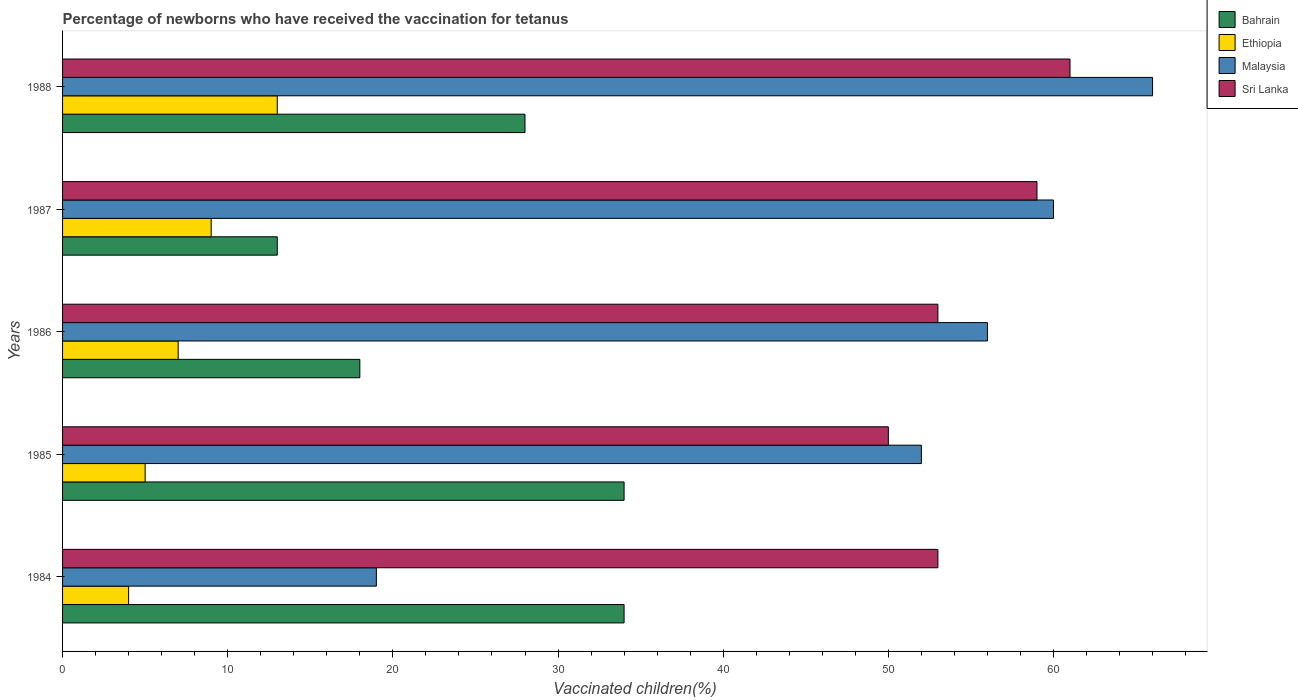Are the number of bars on each tick of the Y-axis equal?
Keep it short and to the point. Yes. How many bars are there on the 3rd tick from the top?
Keep it short and to the point. 4. What is the label of the 4th group of bars from the top?
Give a very brief answer. 1985. Across all years, what is the minimum percentage of vaccinated children in Sri Lanka?
Ensure brevity in your answer.  50. In which year was the percentage of vaccinated children in Malaysia minimum?
Offer a very short reply. 1984. What is the total percentage of vaccinated children in Malaysia in the graph?
Provide a short and direct response. 253. What is the difference between the percentage of vaccinated children in Sri Lanka in 1987 and that in 1988?
Ensure brevity in your answer.  -2. What is the difference between the percentage of vaccinated children in Bahrain in 1984 and the percentage of vaccinated children in Malaysia in 1986?
Your answer should be very brief. -22. What is the average percentage of vaccinated children in Malaysia per year?
Make the answer very short. 50.6. In the year 1988, what is the difference between the percentage of vaccinated children in Malaysia and percentage of vaccinated children in Ethiopia?
Your answer should be compact. 53. What is the ratio of the percentage of vaccinated children in Ethiopia in 1984 to that in 1988?
Offer a terse response. 0.31. Is the percentage of vaccinated children in Ethiopia in 1984 less than that in 1986?
Your answer should be compact. Yes. Is the difference between the percentage of vaccinated children in Malaysia in 1984 and 1987 greater than the difference between the percentage of vaccinated children in Ethiopia in 1984 and 1987?
Ensure brevity in your answer.  No. What is the difference between the highest and the lowest percentage of vaccinated children in Malaysia?
Provide a short and direct response. 47. Is the sum of the percentage of vaccinated children in Ethiopia in 1987 and 1988 greater than the maximum percentage of vaccinated children in Sri Lanka across all years?
Your response must be concise. No. What does the 4th bar from the top in 1986 represents?
Make the answer very short. Bahrain. What does the 2nd bar from the bottom in 1987 represents?
Give a very brief answer. Ethiopia. How many bars are there?
Offer a terse response. 20. Are all the bars in the graph horizontal?
Your answer should be compact. Yes. How many years are there in the graph?
Keep it short and to the point. 5. Are the values on the major ticks of X-axis written in scientific E-notation?
Offer a terse response. No. Where does the legend appear in the graph?
Keep it short and to the point. Top right. How many legend labels are there?
Provide a short and direct response. 4. How are the legend labels stacked?
Provide a succinct answer. Vertical. What is the title of the graph?
Your response must be concise. Percentage of newborns who have received the vaccination for tetanus. What is the label or title of the X-axis?
Keep it short and to the point. Vaccinated children(%). What is the Vaccinated children(%) of Bahrain in 1984?
Offer a very short reply. 34. What is the Vaccinated children(%) of Bahrain in 1985?
Keep it short and to the point. 34. What is the Vaccinated children(%) of Malaysia in 1985?
Provide a succinct answer. 52. What is the Vaccinated children(%) of Sri Lanka in 1985?
Ensure brevity in your answer.  50. What is the Vaccinated children(%) of Ethiopia in 1986?
Ensure brevity in your answer.  7. What is the Vaccinated children(%) of Malaysia in 1986?
Provide a succinct answer. 56. What is the Vaccinated children(%) of Bahrain in 1987?
Your answer should be compact. 13. What is the Vaccinated children(%) in Ethiopia in 1987?
Give a very brief answer. 9. What is the Vaccinated children(%) in Malaysia in 1987?
Provide a short and direct response. 60. What is the Vaccinated children(%) in Bahrain in 1988?
Make the answer very short. 28. What is the Vaccinated children(%) in Ethiopia in 1988?
Your answer should be compact. 13. What is the Vaccinated children(%) of Sri Lanka in 1988?
Ensure brevity in your answer.  61. Across all years, what is the maximum Vaccinated children(%) of Bahrain?
Your response must be concise. 34. Across all years, what is the maximum Vaccinated children(%) in Ethiopia?
Offer a very short reply. 13. Across all years, what is the maximum Vaccinated children(%) of Malaysia?
Ensure brevity in your answer.  66. Across all years, what is the minimum Vaccinated children(%) in Bahrain?
Your answer should be very brief. 13. Across all years, what is the minimum Vaccinated children(%) of Sri Lanka?
Ensure brevity in your answer.  50. What is the total Vaccinated children(%) in Bahrain in the graph?
Your answer should be very brief. 127. What is the total Vaccinated children(%) of Ethiopia in the graph?
Your response must be concise. 38. What is the total Vaccinated children(%) in Malaysia in the graph?
Your response must be concise. 253. What is the total Vaccinated children(%) in Sri Lanka in the graph?
Offer a terse response. 276. What is the difference between the Vaccinated children(%) in Malaysia in 1984 and that in 1985?
Offer a terse response. -33. What is the difference between the Vaccinated children(%) in Ethiopia in 1984 and that in 1986?
Ensure brevity in your answer.  -3. What is the difference between the Vaccinated children(%) of Malaysia in 1984 and that in 1986?
Your answer should be very brief. -37. What is the difference between the Vaccinated children(%) in Sri Lanka in 1984 and that in 1986?
Your answer should be compact. 0. What is the difference between the Vaccinated children(%) in Bahrain in 1984 and that in 1987?
Your response must be concise. 21. What is the difference between the Vaccinated children(%) of Ethiopia in 1984 and that in 1987?
Keep it short and to the point. -5. What is the difference between the Vaccinated children(%) in Malaysia in 1984 and that in 1987?
Offer a very short reply. -41. What is the difference between the Vaccinated children(%) of Malaysia in 1984 and that in 1988?
Provide a succinct answer. -47. What is the difference between the Vaccinated children(%) in Bahrain in 1985 and that in 1987?
Provide a short and direct response. 21. What is the difference between the Vaccinated children(%) in Ethiopia in 1985 and that in 1987?
Offer a very short reply. -4. What is the difference between the Vaccinated children(%) of Sri Lanka in 1985 and that in 1987?
Your answer should be compact. -9. What is the difference between the Vaccinated children(%) in Bahrain in 1985 and that in 1988?
Give a very brief answer. 6. What is the difference between the Vaccinated children(%) of Ethiopia in 1985 and that in 1988?
Provide a succinct answer. -8. What is the difference between the Vaccinated children(%) of Sri Lanka in 1985 and that in 1988?
Your answer should be very brief. -11. What is the difference between the Vaccinated children(%) in Bahrain in 1986 and that in 1987?
Offer a terse response. 5. What is the difference between the Vaccinated children(%) of Sri Lanka in 1986 and that in 1987?
Provide a succinct answer. -6. What is the difference between the Vaccinated children(%) in Bahrain in 1986 and that in 1988?
Provide a succinct answer. -10. What is the difference between the Vaccinated children(%) of Malaysia in 1986 and that in 1988?
Your answer should be very brief. -10. What is the difference between the Vaccinated children(%) of Sri Lanka in 1986 and that in 1988?
Give a very brief answer. -8. What is the difference between the Vaccinated children(%) in Bahrain in 1987 and that in 1988?
Your answer should be very brief. -15. What is the difference between the Vaccinated children(%) in Ethiopia in 1987 and that in 1988?
Provide a short and direct response. -4. What is the difference between the Vaccinated children(%) of Sri Lanka in 1987 and that in 1988?
Offer a terse response. -2. What is the difference between the Vaccinated children(%) of Bahrain in 1984 and the Vaccinated children(%) of Ethiopia in 1985?
Offer a terse response. 29. What is the difference between the Vaccinated children(%) of Ethiopia in 1984 and the Vaccinated children(%) of Malaysia in 1985?
Make the answer very short. -48. What is the difference between the Vaccinated children(%) of Ethiopia in 1984 and the Vaccinated children(%) of Sri Lanka in 1985?
Your answer should be very brief. -46. What is the difference between the Vaccinated children(%) of Malaysia in 1984 and the Vaccinated children(%) of Sri Lanka in 1985?
Provide a short and direct response. -31. What is the difference between the Vaccinated children(%) in Ethiopia in 1984 and the Vaccinated children(%) in Malaysia in 1986?
Give a very brief answer. -52. What is the difference between the Vaccinated children(%) of Ethiopia in 1984 and the Vaccinated children(%) of Sri Lanka in 1986?
Give a very brief answer. -49. What is the difference between the Vaccinated children(%) in Malaysia in 1984 and the Vaccinated children(%) in Sri Lanka in 1986?
Give a very brief answer. -34. What is the difference between the Vaccinated children(%) of Bahrain in 1984 and the Vaccinated children(%) of Ethiopia in 1987?
Your answer should be compact. 25. What is the difference between the Vaccinated children(%) in Bahrain in 1984 and the Vaccinated children(%) in Sri Lanka in 1987?
Give a very brief answer. -25. What is the difference between the Vaccinated children(%) of Ethiopia in 1984 and the Vaccinated children(%) of Malaysia in 1987?
Your response must be concise. -56. What is the difference between the Vaccinated children(%) of Ethiopia in 1984 and the Vaccinated children(%) of Sri Lanka in 1987?
Provide a succinct answer. -55. What is the difference between the Vaccinated children(%) of Bahrain in 1984 and the Vaccinated children(%) of Ethiopia in 1988?
Provide a succinct answer. 21. What is the difference between the Vaccinated children(%) of Bahrain in 1984 and the Vaccinated children(%) of Malaysia in 1988?
Provide a short and direct response. -32. What is the difference between the Vaccinated children(%) in Ethiopia in 1984 and the Vaccinated children(%) in Malaysia in 1988?
Your response must be concise. -62. What is the difference between the Vaccinated children(%) in Ethiopia in 1984 and the Vaccinated children(%) in Sri Lanka in 1988?
Ensure brevity in your answer.  -57. What is the difference between the Vaccinated children(%) in Malaysia in 1984 and the Vaccinated children(%) in Sri Lanka in 1988?
Give a very brief answer. -42. What is the difference between the Vaccinated children(%) in Ethiopia in 1985 and the Vaccinated children(%) in Malaysia in 1986?
Your response must be concise. -51. What is the difference between the Vaccinated children(%) of Ethiopia in 1985 and the Vaccinated children(%) of Sri Lanka in 1986?
Provide a succinct answer. -48. What is the difference between the Vaccinated children(%) in Malaysia in 1985 and the Vaccinated children(%) in Sri Lanka in 1986?
Provide a short and direct response. -1. What is the difference between the Vaccinated children(%) in Bahrain in 1985 and the Vaccinated children(%) in Ethiopia in 1987?
Offer a terse response. 25. What is the difference between the Vaccinated children(%) in Ethiopia in 1985 and the Vaccinated children(%) in Malaysia in 1987?
Your answer should be compact. -55. What is the difference between the Vaccinated children(%) in Ethiopia in 1985 and the Vaccinated children(%) in Sri Lanka in 1987?
Provide a short and direct response. -54. What is the difference between the Vaccinated children(%) of Bahrain in 1985 and the Vaccinated children(%) of Malaysia in 1988?
Ensure brevity in your answer.  -32. What is the difference between the Vaccinated children(%) of Bahrain in 1985 and the Vaccinated children(%) of Sri Lanka in 1988?
Make the answer very short. -27. What is the difference between the Vaccinated children(%) of Ethiopia in 1985 and the Vaccinated children(%) of Malaysia in 1988?
Keep it short and to the point. -61. What is the difference between the Vaccinated children(%) in Ethiopia in 1985 and the Vaccinated children(%) in Sri Lanka in 1988?
Provide a succinct answer. -56. What is the difference between the Vaccinated children(%) in Bahrain in 1986 and the Vaccinated children(%) in Malaysia in 1987?
Ensure brevity in your answer.  -42. What is the difference between the Vaccinated children(%) in Bahrain in 1986 and the Vaccinated children(%) in Sri Lanka in 1987?
Provide a succinct answer. -41. What is the difference between the Vaccinated children(%) in Ethiopia in 1986 and the Vaccinated children(%) in Malaysia in 1987?
Ensure brevity in your answer.  -53. What is the difference between the Vaccinated children(%) of Ethiopia in 1986 and the Vaccinated children(%) of Sri Lanka in 1987?
Ensure brevity in your answer.  -52. What is the difference between the Vaccinated children(%) of Bahrain in 1986 and the Vaccinated children(%) of Malaysia in 1988?
Your response must be concise. -48. What is the difference between the Vaccinated children(%) in Bahrain in 1986 and the Vaccinated children(%) in Sri Lanka in 1988?
Keep it short and to the point. -43. What is the difference between the Vaccinated children(%) in Ethiopia in 1986 and the Vaccinated children(%) in Malaysia in 1988?
Give a very brief answer. -59. What is the difference between the Vaccinated children(%) in Ethiopia in 1986 and the Vaccinated children(%) in Sri Lanka in 1988?
Provide a short and direct response. -54. What is the difference between the Vaccinated children(%) of Malaysia in 1986 and the Vaccinated children(%) of Sri Lanka in 1988?
Provide a short and direct response. -5. What is the difference between the Vaccinated children(%) in Bahrain in 1987 and the Vaccinated children(%) in Ethiopia in 1988?
Offer a terse response. 0. What is the difference between the Vaccinated children(%) of Bahrain in 1987 and the Vaccinated children(%) of Malaysia in 1988?
Give a very brief answer. -53. What is the difference between the Vaccinated children(%) in Bahrain in 1987 and the Vaccinated children(%) in Sri Lanka in 1988?
Offer a very short reply. -48. What is the difference between the Vaccinated children(%) in Ethiopia in 1987 and the Vaccinated children(%) in Malaysia in 1988?
Provide a short and direct response. -57. What is the difference between the Vaccinated children(%) in Ethiopia in 1987 and the Vaccinated children(%) in Sri Lanka in 1988?
Keep it short and to the point. -52. What is the difference between the Vaccinated children(%) in Malaysia in 1987 and the Vaccinated children(%) in Sri Lanka in 1988?
Your answer should be compact. -1. What is the average Vaccinated children(%) in Bahrain per year?
Give a very brief answer. 25.4. What is the average Vaccinated children(%) of Malaysia per year?
Provide a short and direct response. 50.6. What is the average Vaccinated children(%) in Sri Lanka per year?
Your response must be concise. 55.2. In the year 1984, what is the difference between the Vaccinated children(%) in Bahrain and Vaccinated children(%) in Malaysia?
Your response must be concise. 15. In the year 1984, what is the difference between the Vaccinated children(%) of Ethiopia and Vaccinated children(%) of Sri Lanka?
Keep it short and to the point. -49. In the year 1984, what is the difference between the Vaccinated children(%) of Malaysia and Vaccinated children(%) of Sri Lanka?
Offer a terse response. -34. In the year 1985, what is the difference between the Vaccinated children(%) in Bahrain and Vaccinated children(%) in Ethiopia?
Your answer should be very brief. 29. In the year 1985, what is the difference between the Vaccinated children(%) of Ethiopia and Vaccinated children(%) of Malaysia?
Your response must be concise. -47. In the year 1985, what is the difference between the Vaccinated children(%) in Ethiopia and Vaccinated children(%) in Sri Lanka?
Your response must be concise. -45. In the year 1986, what is the difference between the Vaccinated children(%) of Bahrain and Vaccinated children(%) of Malaysia?
Keep it short and to the point. -38. In the year 1986, what is the difference between the Vaccinated children(%) of Bahrain and Vaccinated children(%) of Sri Lanka?
Provide a succinct answer. -35. In the year 1986, what is the difference between the Vaccinated children(%) of Ethiopia and Vaccinated children(%) of Malaysia?
Provide a short and direct response. -49. In the year 1986, what is the difference between the Vaccinated children(%) of Ethiopia and Vaccinated children(%) of Sri Lanka?
Offer a terse response. -46. In the year 1987, what is the difference between the Vaccinated children(%) of Bahrain and Vaccinated children(%) of Malaysia?
Offer a terse response. -47. In the year 1987, what is the difference between the Vaccinated children(%) in Bahrain and Vaccinated children(%) in Sri Lanka?
Offer a terse response. -46. In the year 1987, what is the difference between the Vaccinated children(%) in Ethiopia and Vaccinated children(%) in Malaysia?
Your response must be concise. -51. In the year 1987, what is the difference between the Vaccinated children(%) of Ethiopia and Vaccinated children(%) of Sri Lanka?
Your answer should be very brief. -50. In the year 1987, what is the difference between the Vaccinated children(%) of Malaysia and Vaccinated children(%) of Sri Lanka?
Your answer should be very brief. 1. In the year 1988, what is the difference between the Vaccinated children(%) of Bahrain and Vaccinated children(%) of Malaysia?
Your answer should be very brief. -38. In the year 1988, what is the difference between the Vaccinated children(%) in Bahrain and Vaccinated children(%) in Sri Lanka?
Provide a short and direct response. -33. In the year 1988, what is the difference between the Vaccinated children(%) in Ethiopia and Vaccinated children(%) in Malaysia?
Your answer should be very brief. -53. In the year 1988, what is the difference between the Vaccinated children(%) of Ethiopia and Vaccinated children(%) of Sri Lanka?
Offer a very short reply. -48. What is the ratio of the Vaccinated children(%) in Bahrain in 1984 to that in 1985?
Your response must be concise. 1. What is the ratio of the Vaccinated children(%) in Ethiopia in 1984 to that in 1985?
Ensure brevity in your answer.  0.8. What is the ratio of the Vaccinated children(%) of Malaysia in 1984 to that in 1985?
Your response must be concise. 0.37. What is the ratio of the Vaccinated children(%) of Sri Lanka in 1984 to that in 1985?
Provide a short and direct response. 1.06. What is the ratio of the Vaccinated children(%) of Bahrain in 1984 to that in 1986?
Give a very brief answer. 1.89. What is the ratio of the Vaccinated children(%) of Ethiopia in 1984 to that in 1986?
Your answer should be very brief. 0.57. What is the ratio of the Vaccinated children(%) of Malaysia in 1984 to that in 1986?
Give a very brief answer. 0.34. What is the ratio of the Vaccinated children(%) in Sri Lanka in 1984 to that in 1986?
Provide a succinct answer. 1. What is the ratio of the Vaccinated children(%) of Bahrain in 1984 to that in 1987?
Your answer should be compact. 2.62. What is the ratio of the Vaccinated children(%) of Ethiopia in 1984 to that in 1987?
Your response must be concise. 0.44. What is the ratio of the Vaccinated children(%) of Malaysia in 1984 to that in 1987?
Provide a succinct answer. 0.32. What is the ratio of the Vaccinated children(%) in Sri Lanka in 1984 to that in 1987?
Your answer should be very brief. 0.9. What is the ratio of the Vaccinated children(%) in Bahrain in 1984 to that in 1988?
Your answer should be very brief. 1.21. What is the ratio of the Vaccinated children(%) of Ethiopia in 1984 to that in 1988?
Your answer should be compact. 0.31. What is the ratio of the Vaccinated children(%) of Malaysia in 1984 to that in 1988?
Your response must be concise. 0.29. What is the ratio of the Vaccinated children(%) in Sri Lanka in 1984 to that in 1988?
Keep it short and to the point. 0.87. What is the ratio of the Vaccinated children(%) in Bahrain in 1985 to that in 1986?
Provide a succinct answer. 1.89. What is the ratio of the Vaccinated children(%) in Ethiopia in 1985 to that in 1986?
Offer a terse response. 0.71. What is the ratio of the Vaccinated children(%) in Sri Lanka in 1985 to that in 1986?
Make the answer very short. 0.94. What is the ratio of the Vaccinated children(%) in Bahrain in 1985 to that in 1987?
Your answer should be compact. 2.62. What is the ratio of the Vaccinated children(%) in Ethiopia in 1985 to that in 1987?
Offer a terse response. 0.56. What is the ratio of the Vaccinated children(%) of Malaysia in 1985 to that in 1987?
Offer a terse response. 0.87. What is the ratio of the Vaccinated children(%) of Sri Lanka in 1985 to that in 1987?
Provide a short and direct response. 0.85. What is the ratio of the Vaccinated children(%) in Bahrain in 1985 to that in 1988?
Give a very brief answer. 1.21. What is the ratio of the Vaccinated children(%) in Ethiopia in 1985 to that in 1988?
Offer a terse response. 0.38. What is the ratio of the Vaccinated children(%) of Malaysia in 1985 to that in 1988?
Offer a terse response. 0.79. What is the ratio of the Vaccinated children(%) in Sri Lanka in 1985 to that in 1988?
Ensure brevity in your answer.  0.82. What is the ratio of the Vaccinated children(%) in Bahrain in 1986 to that in 1987?
Ensure brevity in your answer.  1.38. What is the ratio of the Vaccinated children(%) of Sri Lanka in 1986 to that in 1987?
Offer a very short reply. 0.9. What is the ratio of the Vaccinated children(%) of Bahrain in 1986 to that in 1988?
Offer a very short reply. 0.64. What is the ratio of the Vaccinated children(%) in Ethiopia in 1986 to that in 1988?
Offer a terse response. 0.54. What is the ratio of the Vaccinated children(%) in Malaysia in 1986 to that in 1988?
Offer a terse response. 0.85. What is the ratio of the Vaccinated children(%) in Sri Lanka in 1986 to that in 1988?
Your response must be concise. 0.87. What is the ratio of the Vaccinated children(%) of Bahrain in 1987 to that in 1988?
Make the answer very short. 0.46. What is the ratio of the Vaccinated children(%) of Ethiopia in 1987 to that in 1988?
Offer a very short reply. 0.69. What is the ratio of the Vaccinated children(%) of Sri Lanka in 1987 to that in 1988?
Give a very brief answer. 0.97. What is the difference between the highest and the second highest Vaccinated children(%) in Ethiopia?
Offer a terse response. 4. What is the difference between the highest and the lowest Vaccinated children(%) in Bahrain?
Make the answer very short. 21. What is the difference between the highest and the lowest Vaccinated children(%) of Malaysia?
Your response must be concise. 47. 